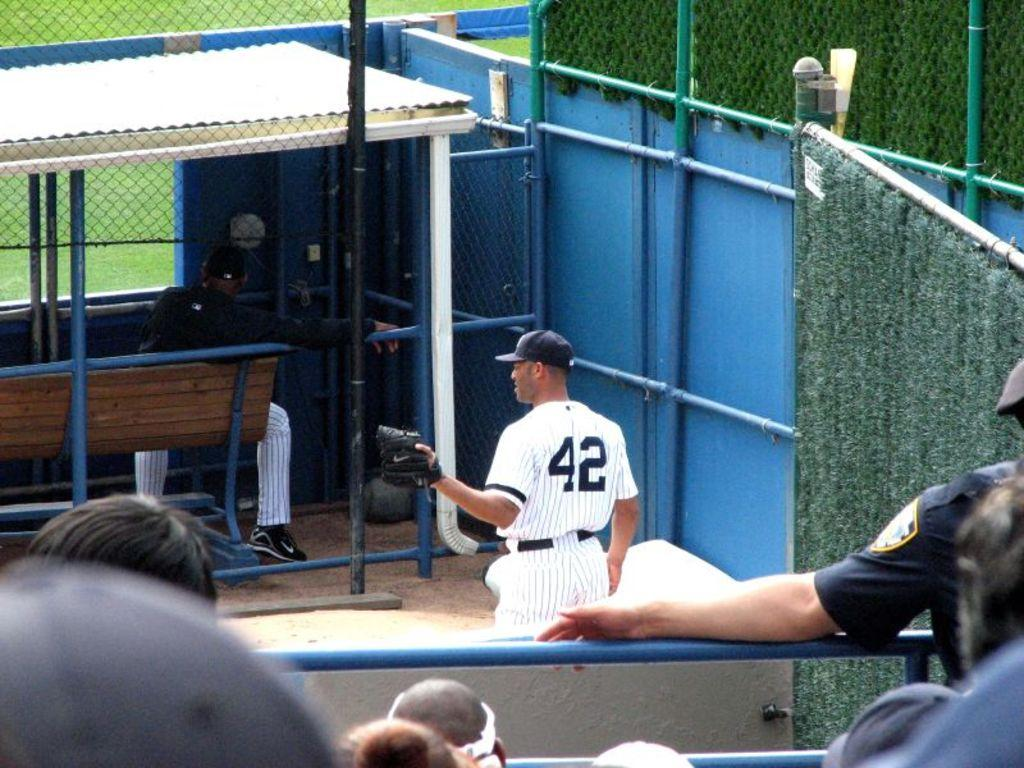<image>
Relay a brief, clear account of the picture shown. A baseball player with the jersey 42 stepping out the dugout 